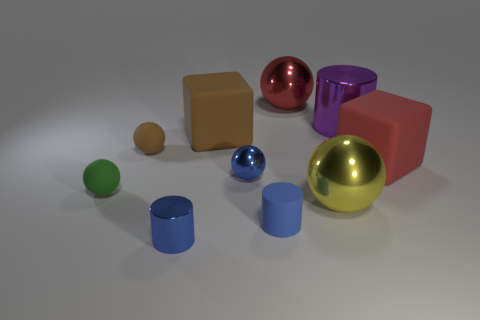Does the blue metallic object that is on the left side of the brown block have the same size as the big brown block?
Offer a very short reply. No. What is the material of the green object that is the same shape as the big red metal object?
Ensure brevity in your answer.  Rubber. Is the shape of the large red rubber thing the same as the large brown object?
Offer a very short reply. Yes. What number of tiny rubber balls are in front of the big rubber thing to the right of the large yellow metal ball?
Make the answer very short. 1. What shape is the big red thing that is the same material as the small brown object?
Ensure brevity in your answer.  Cube. How many blue things are shiny cylinders or big cylinders?
Your response must be concise. 1. There is a cylinder behind the small rubber object that is in front of the small green matte thing; is there a matte cube on the left side of it?
Offer a terse response. Yes. Is the number of brown matte objects less than the number of small rubber things?
Your response must be concise. Yes. Is the shape of the big thing that is in front of the large red block the same as  the tiny brown matte thing?
Give a very brief answer. Yes. Are any big brown rubber objects visible?
Your answer should be compact. Yes. 